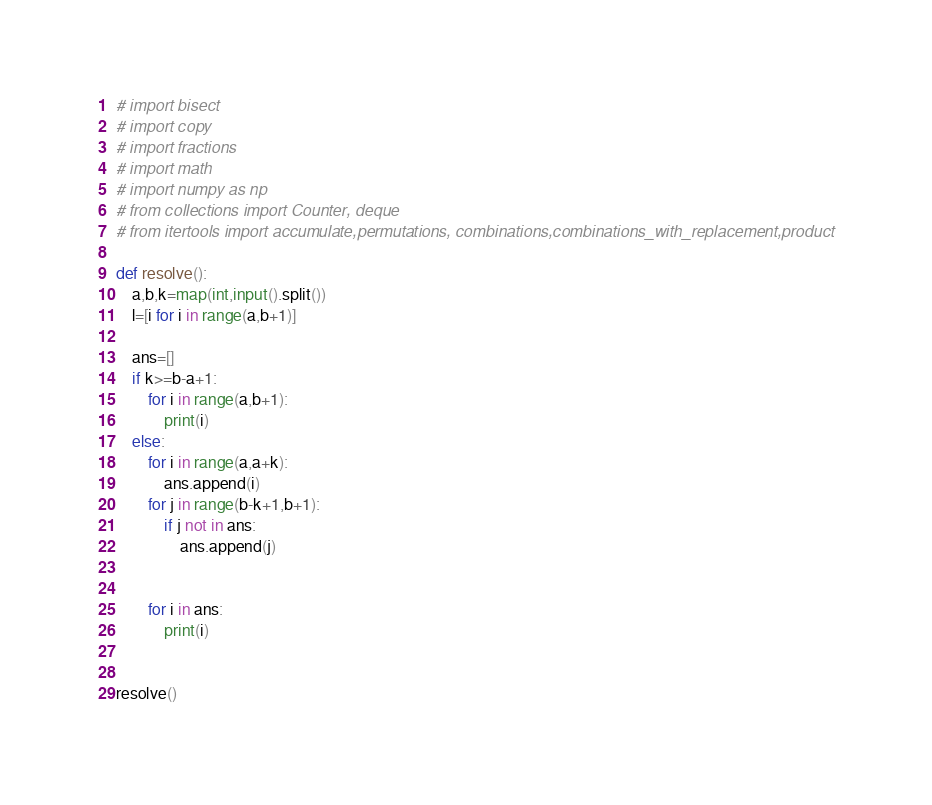Convert code to text. <code><loc_0><loc_0><loc_500><loc_500><_Python_># import bisect
# import copy
# import fractions
# import math
# import numpy as np
# from collections import Counter, deque
# from itertools import accumulate,permutations, combinations,combinations_with_replacement,product

def resolve():
    a,b,k=map(int,input().split())
    l=[i for i in range(a,b+1)]

    ans=[]
    if k>=b-a+1:
        for i in range(a,b+1):
            print(i)
    else:
        for i in range(a,a+k):
            ans.append(i)
        for j in range(b-k+1,b+1):
            if j not in ans:
                ans.append(j)


        for i in ans:
            print(i)


resolve()</code> 